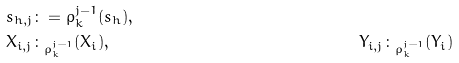<formula> <loc_0><loc_0><loc_500><loc_500>& s _ { h , j } \colon = \rho _ { k } ^ { j - 1 } ( s _ { h } ) , & & & \\ & X _ { i , j } \colon _ { \rho _ { k } ^ { j - 1 } } ( X _ { i } ) , & & Y _ { i , j } \colon _ { \rho _ { k } ^ { j - 1 } } ( Y _ { i } ) &</formula> 